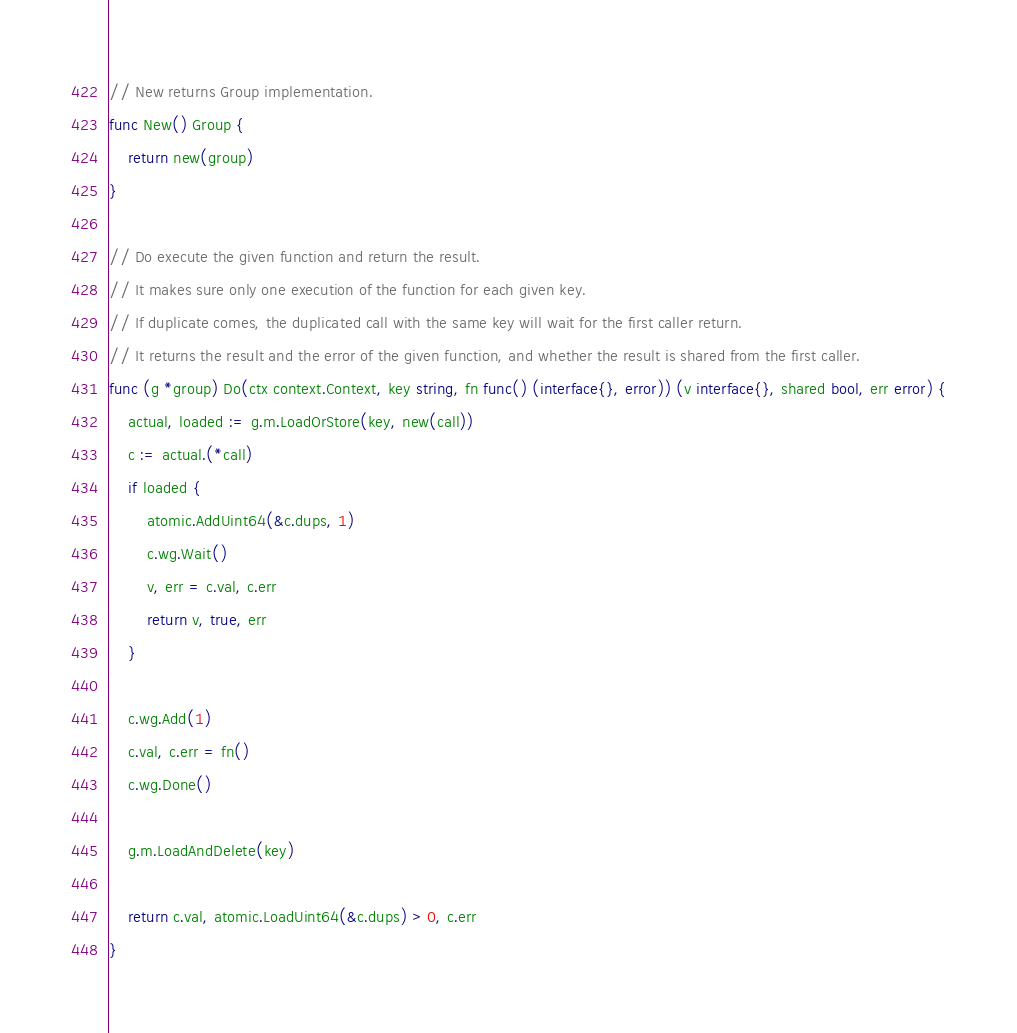Convert code to text. <code><loc_0><loc_0><loc_500><loc_500><_Go_>// New returns Group implementation.
func New() Group {
	return new(group)
}

// Do execute the given function and return the result.
// It makes sure only one execution of the function for each given key.
// If duplicate comes, the duplicated call with the same key will wait for the first caller return.
// It returns the result and the error of the given function, and whether the result is shared from the first caller.
func (g *group) Do(ctx context.Context, key string, fn func() (interface{}, error)) (v interface{}, shared bool, err error) {
	actual, loaded := g.m.LoadOrStore(key, new(call))
	c := actual.(*call)
	if loaded {
		atomic.AddUint64(&c.dups, 1)
		c.wg.Wait()
		v, err = c.val, c.err
		return v, true, err
	}

	c.wg.Add(1)
	c.val, c.err = fn()
	c.wg.Done()

	g.m.LoadAndDelete(key)

	return c.val, atomic.LoadUint64(&c.dups) > 0, c.err
}
</code> 